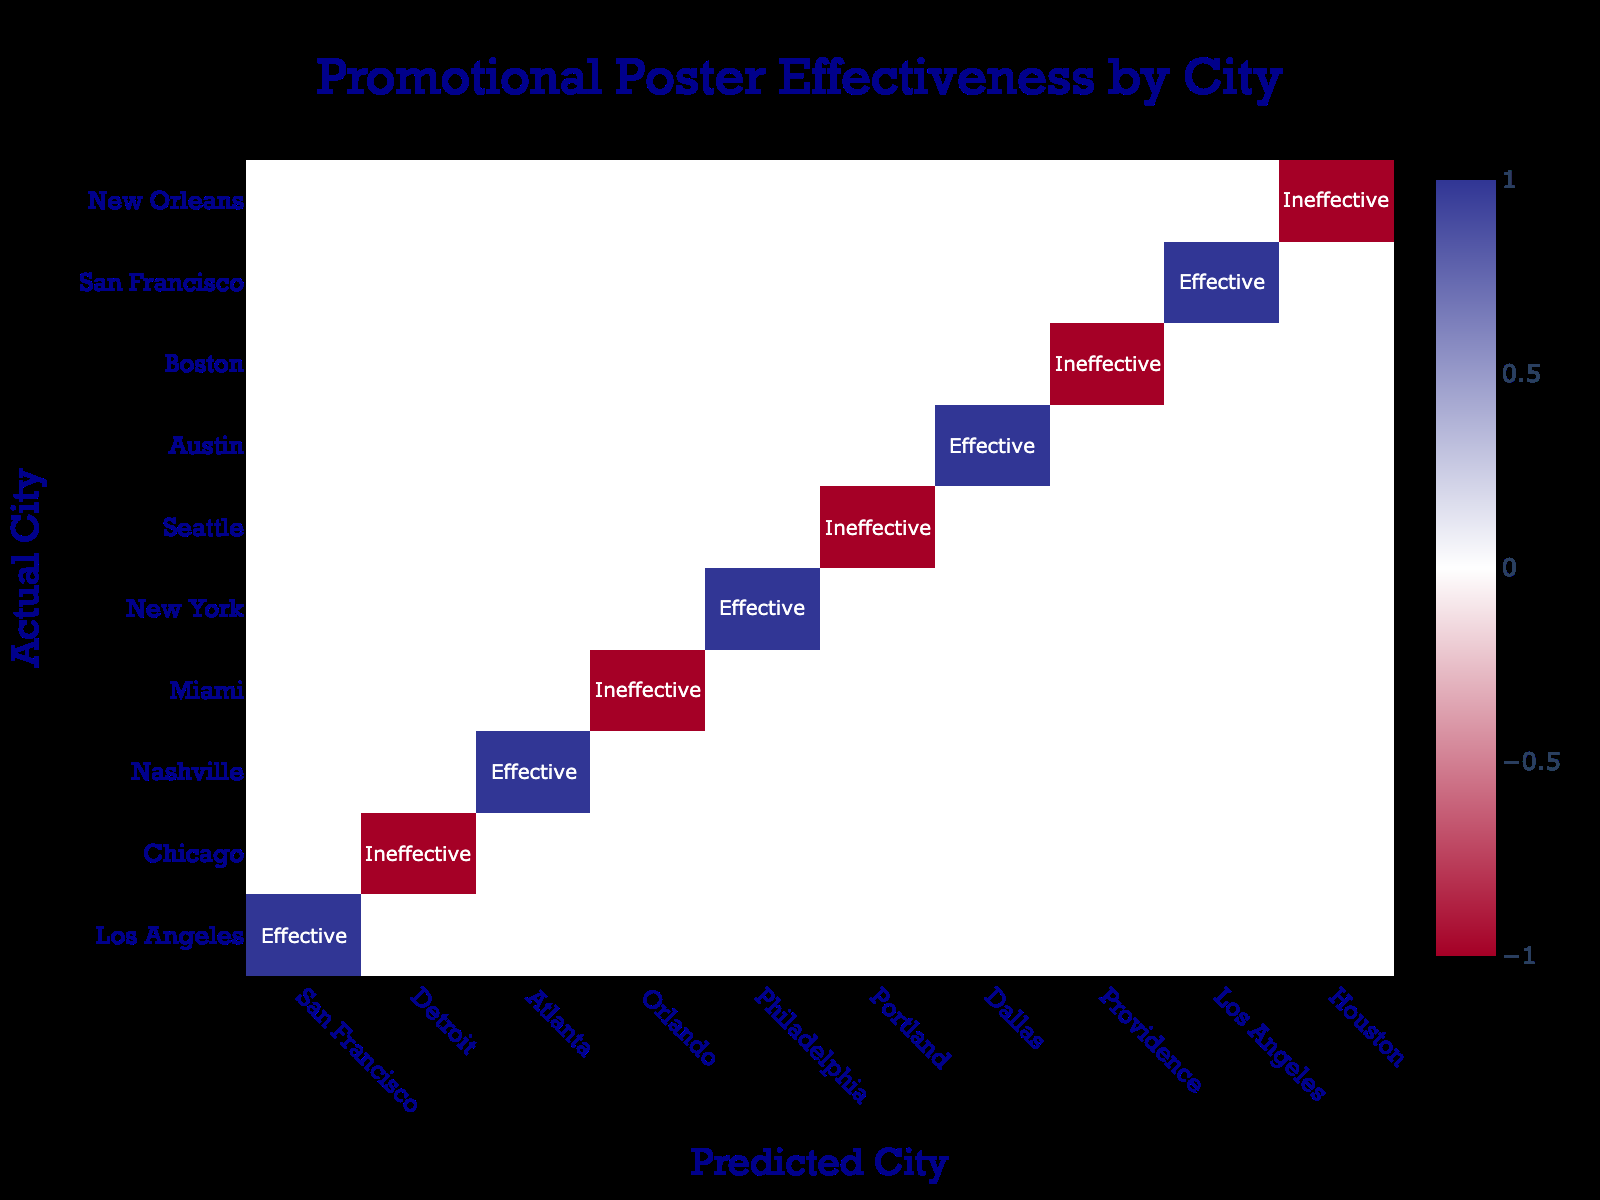What is the predicted city for Los Angeles? The table indicates that when the actual city is Los Angeles, the predicted city is San Francisco
Answer: San Francisco How many cities were predicted to be effective? The table shows that there are 5 instances labeled as "Effective": San Francisco, Nashville, New York, Austin, and Los Angeles. Thus, there are 5 effective predictions.
Answer: 5 Is Miami predicted to be effective or ineffective? According to the table, Miami is predicted as Orlando, which is listed as "Ineffective."
Answer: Ineffective Which actual city was consistently predicted to be effective? Analyzing the table, Los Angeles is predicted as effective in both its original context as the actual city and when it is listed under effective predictions.
Answer: Los Angeles What is the ratio of effective to ineffective predictions? From the table, there are 5 effective predictions and 5 ineffective predictions, thus the ratio is 5:5, which simplifies to 1:1.
Answer: 1:1 Which actual city has the highest prediction outcome counted as ineffective? By examining the table, Chicago is listed as ineffective when predicted for Detroit, and it is the only actual city mentioned under that outcome.
Answer: Chicago How many ineffective predictions are there for southern cities? The cities Miami and New Orleans are predicted to be ineffective, making a total of 2 ineffective predictions from southern cities.
Answer: 2 Are there any cities predicted to be both effective and ineffective? By reviewing the table, it is clear that each city listed is predicted as either effective or ineffective, but none appear under both categories for any given prediction.
Answer: No 